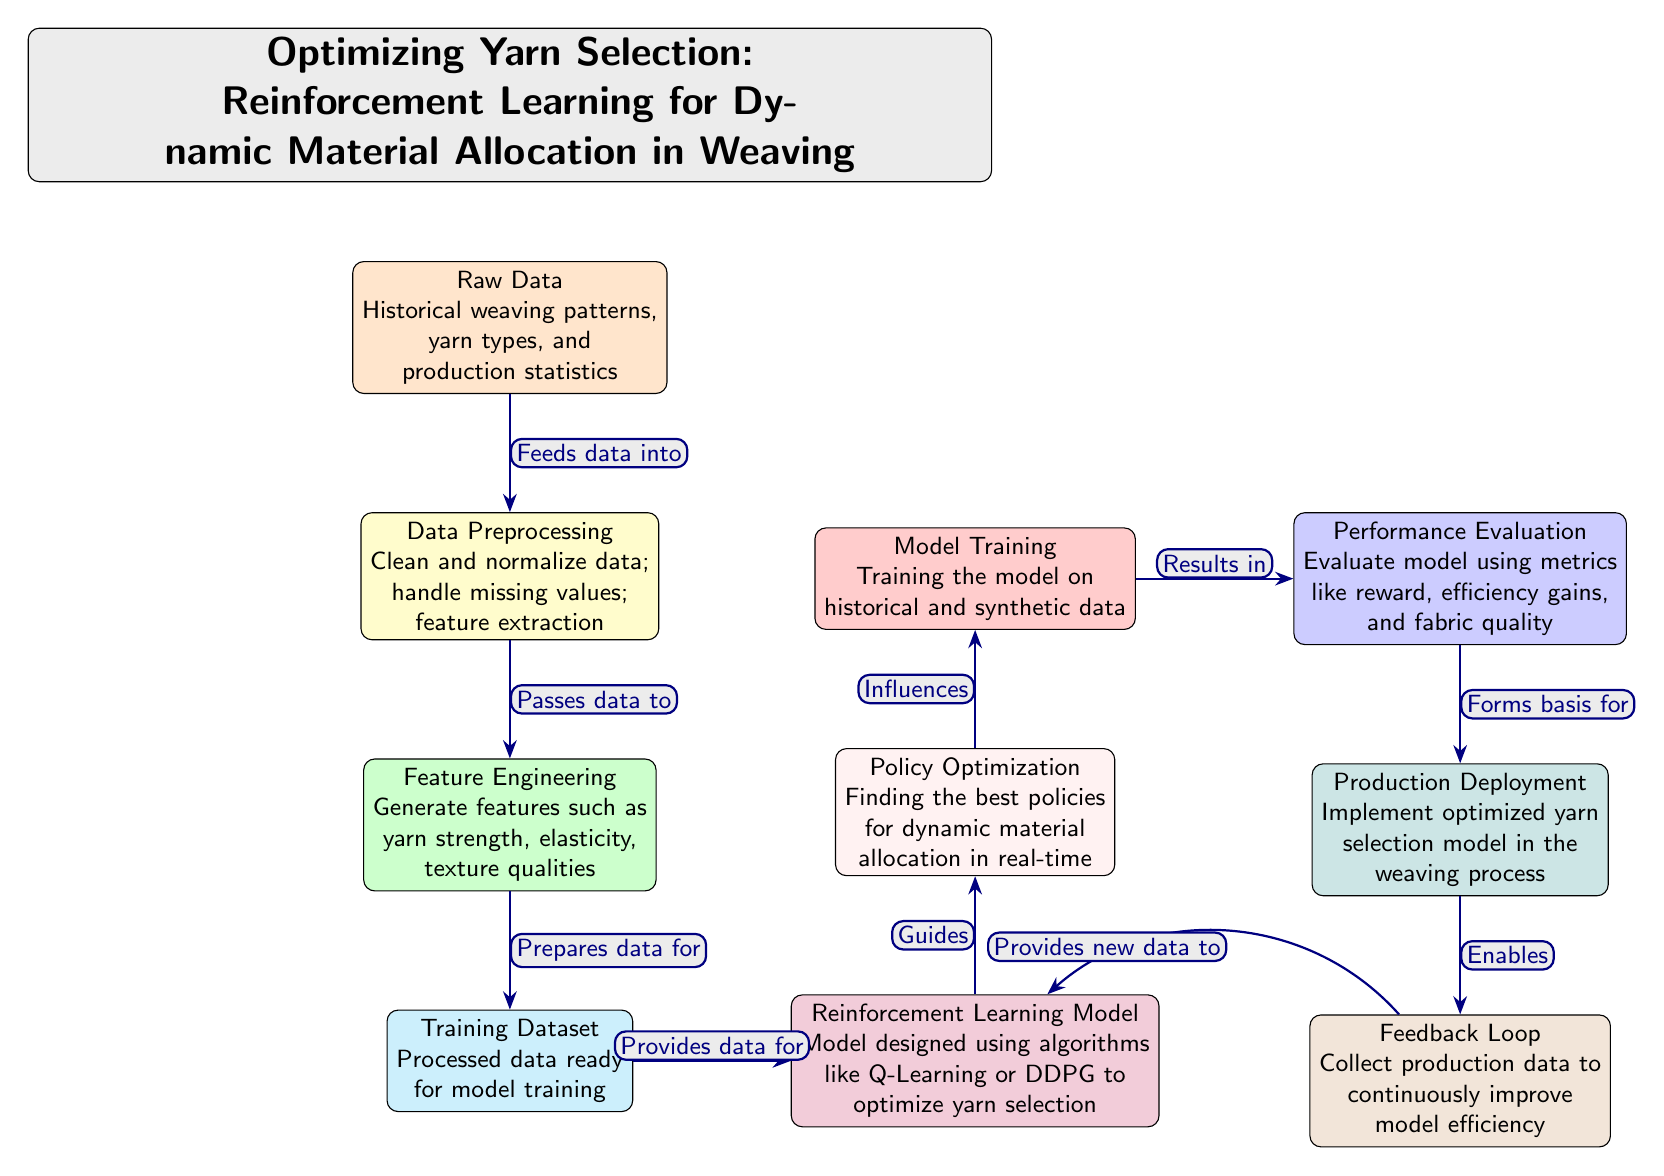What is the first step in the diagram? The diagram starts with the "Raw Data" node, which includes historical weaving patterns, yarn types, and production statistics. Hence, the first step is to gather this data.
Answer: Raw Data How many nodes are in the diagram? By counting the distinct nodes visually represented, we see that there are a total of 10 nodes in the diagram, representing various steps in the process.
Answer: 10 What feeds data into the Data Preprocessing step? The arrow from the "Raw Data" node points directly to the "Data Preprocessing" node, indicating that the raw data is what feeds into this step.
Answer: Raw Data What processes follow the Policy Optimization step? The "Policy Optimization" step influences the "Model Training" step directly above it in the flow of the diagram, indicating that after policy optimization, model training occurs.
Answer: Model Training What does the Feedback Loop enable? The "Feedback Loop" node is shown to enable the reinforcement learning model (indicated by an arrow that points to the "Reinforcement Learning Model") to continuously improve in efficiency through new data gathered after production deployment.
Answer: Continuous improvement What is evaluated in the Performance Evaluation step? The "Performance Evaluation" step typically includes metrics such as reward, efficiency gains, and fabric quality, as mentioned in the node description. These are the main factors evaluated in this step.
Answer: Reward, efficiency gains, and fabric quality Which step prepares data for the Reinforcement Learning Model? The "Training Dataset" node directly provides data for the "Reinforcement Learning Model" step, making it the key preparatory stage for the model's data.
Answer: Training Dataset Which model designs use algorithms like Q-Learning or DDPG? The "Reinforcement Learning Model" is specifically mentioned as being designed using algorithms like Q-Learning or DDPG to optimize yarn selection, indicating its focus on these algorithms.
Answer: Reinforcement Learning Model What does the Production Deployment step implement? The "Production Deployment" node implements the optimized yarn selection model within the weaving process, as stated in the associated text of the node.
Answer: Optimized yarn selection model 